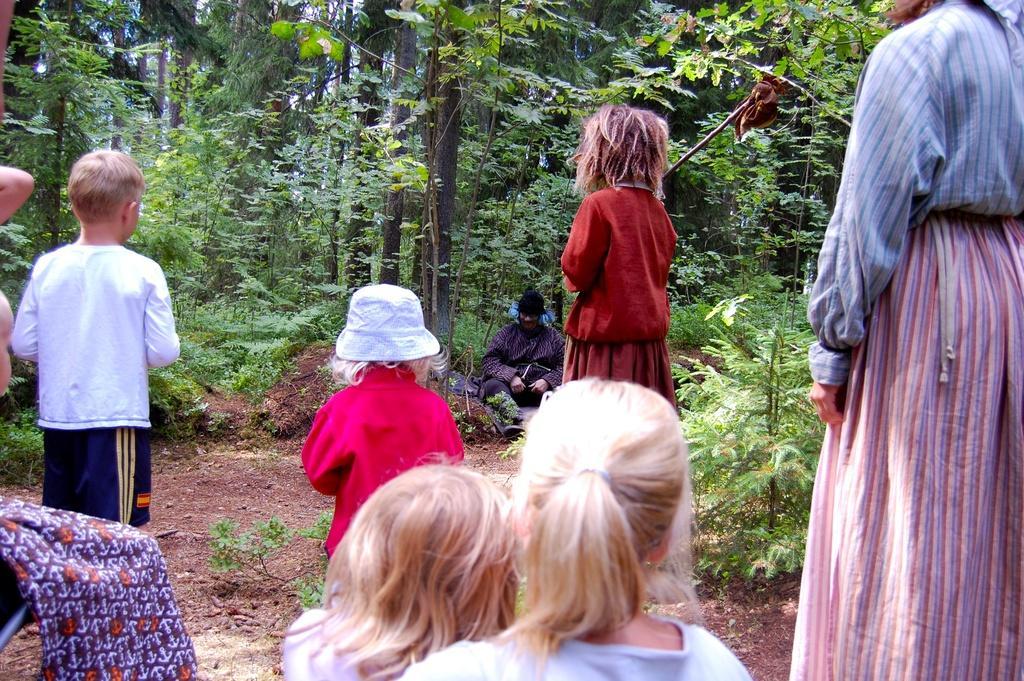Could you give a brief overview of what you see in this image? In this picture there are people and we can see plants and trees. In the bottom left side of the image we can see cloth. 